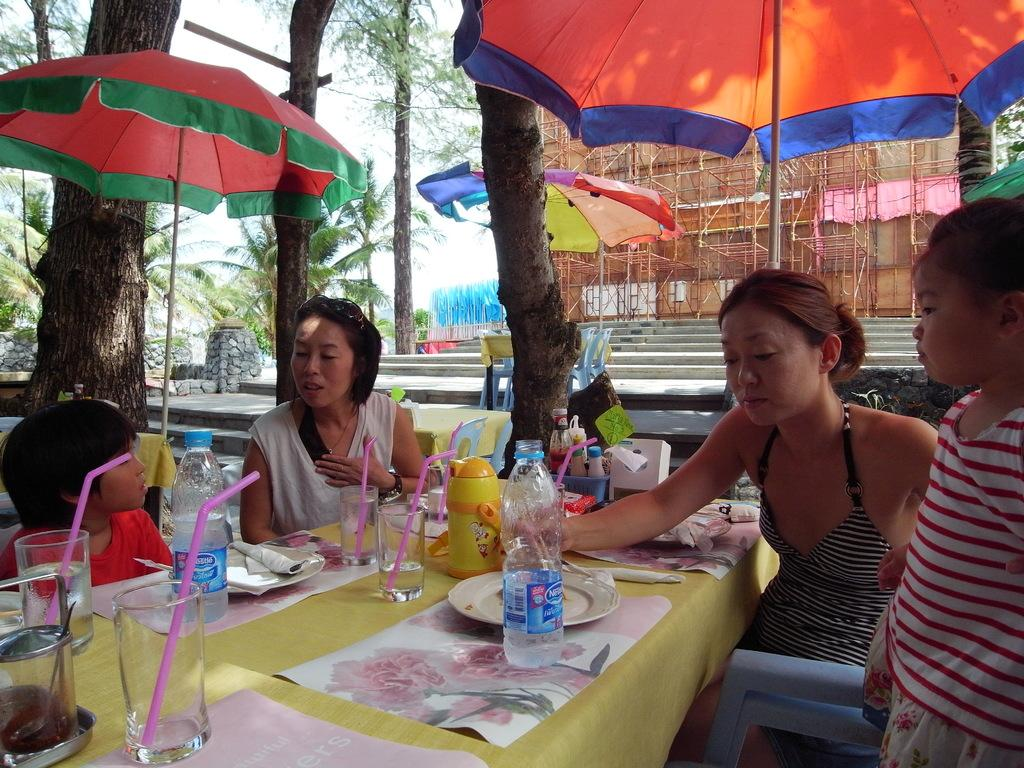What are the people in the image doing? There is a group of people seated in the image. What is on the table in the image? Water bottles, glasses, and plates are present on the table. How many umbrellas can be seen in the image? There are two umbrellas in the image. What type of writing can be seen on the plates in the image? There is no writing visible on the plates in the image. How many snails are crawling on the table in the image? There are no snails present in the image. 